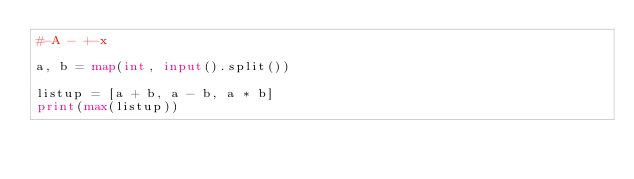<code> <loc_0><loc_0><loc_500><loc_500><_Python_>#-A - +-x

a, b = map(int, input().split())

listup = [a + b, a - b, a * b]
print(max(listup))
</code> 